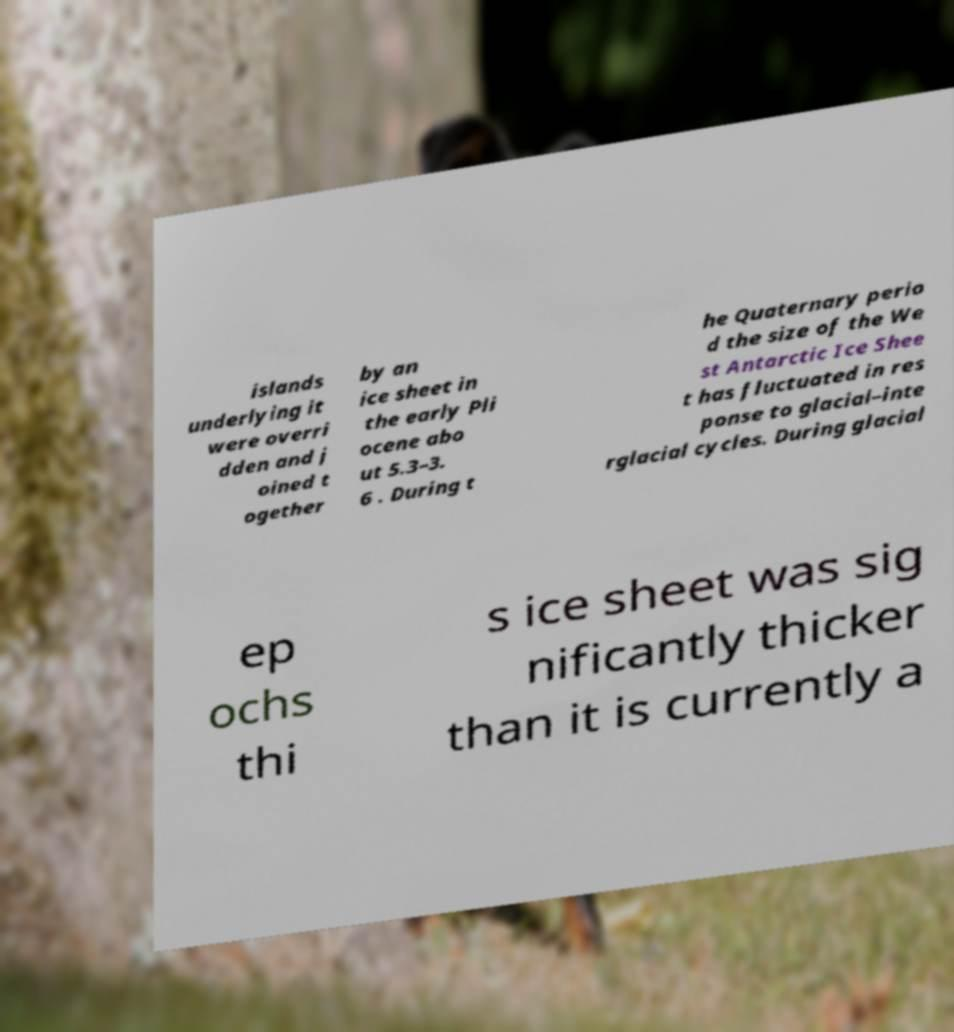I need the written content from this picture converted into text. Can you do that? islands underlying it were overri dden and j oined t ogether by an ice sheet in the early Pli ocene abo ut 5.3–3. 6 . During t he Quaternary perio d the size of the We st Antarctic Ice Shee t has fluctuated in res ponse to glacial–inte rglacial cycles. During glacial ep ochs thi s ice sheet was sig nificantly thicker than it is currently a 